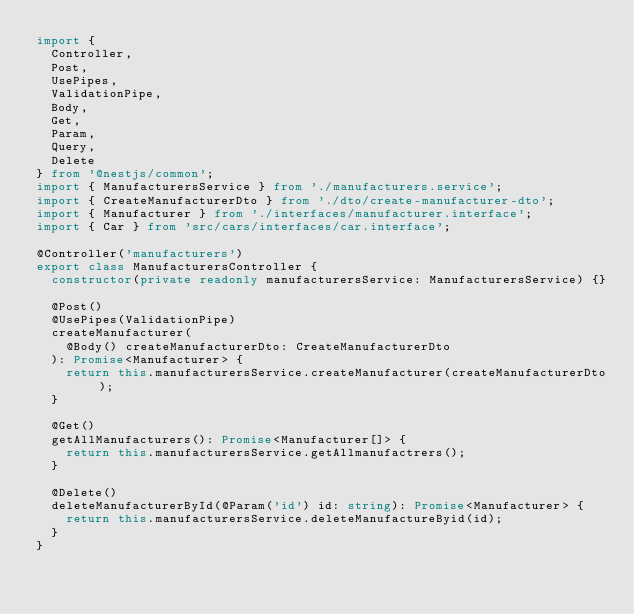Convert code to text. <code><loc_0><loc_0><loc_500><loc_500><_TypeScript_>import {
  Controller,
  Post,
  UsePipes,
  ValidationPipe,
  Body,
  Get,
  Param,
  Query,
  Delete
} from '@nestjs/common';
import { ManufacturersService } from './manufacturers.service';
import { CreateManufacturerDto } from './dto/create-manufacturer-dto';
import { Manufacturer } from './interfaces/manufacturer.interface';
import { Car } from 'src/cars/interfaces/car.interface';

@Controller('manufacturers')
export class ManufacturersController {
  constructor(private readonly manufacturersService: ManufacturersService) {}

  @Post()
  @UsePipes(ValidationPipe)
  createManufacturer(
    @Body() createManufacturerDto: CreateManufacturerDto
  ): Promise<Manufacturer> {
    return this.manufacturersService.createManufacturer(createManufacturerDto);
  }

  @Get()
  getAllManufacturers(): Promise<Manufacturer[]> {
    return this.manufacturersService.getAllmanufactrers();
  }

  @Delete()
  deleteManufacturerById(@Param('id') id: string): Promise<Manufacturer> {
    return this.manufacturersService.deleteManufactureByid(id);
  }
}
</code> 